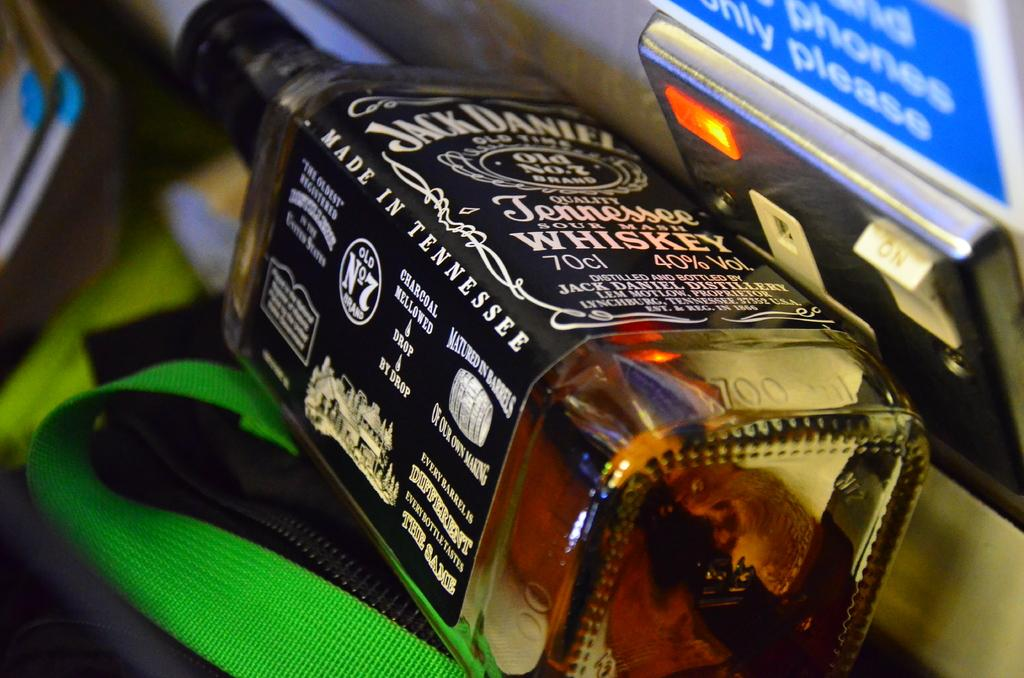What type of bottle is shown in the image? The object is a Jack Daniel's wine bottle. Can you describe the label or branding on the bottle? The bottle has the Jack Daniel's branding on it. Where is the nest of birds located on the wine bottle? There is no nest of birds present on the wine bottle; it is a Jack Daniel's bottle with no nest or birds visible. 